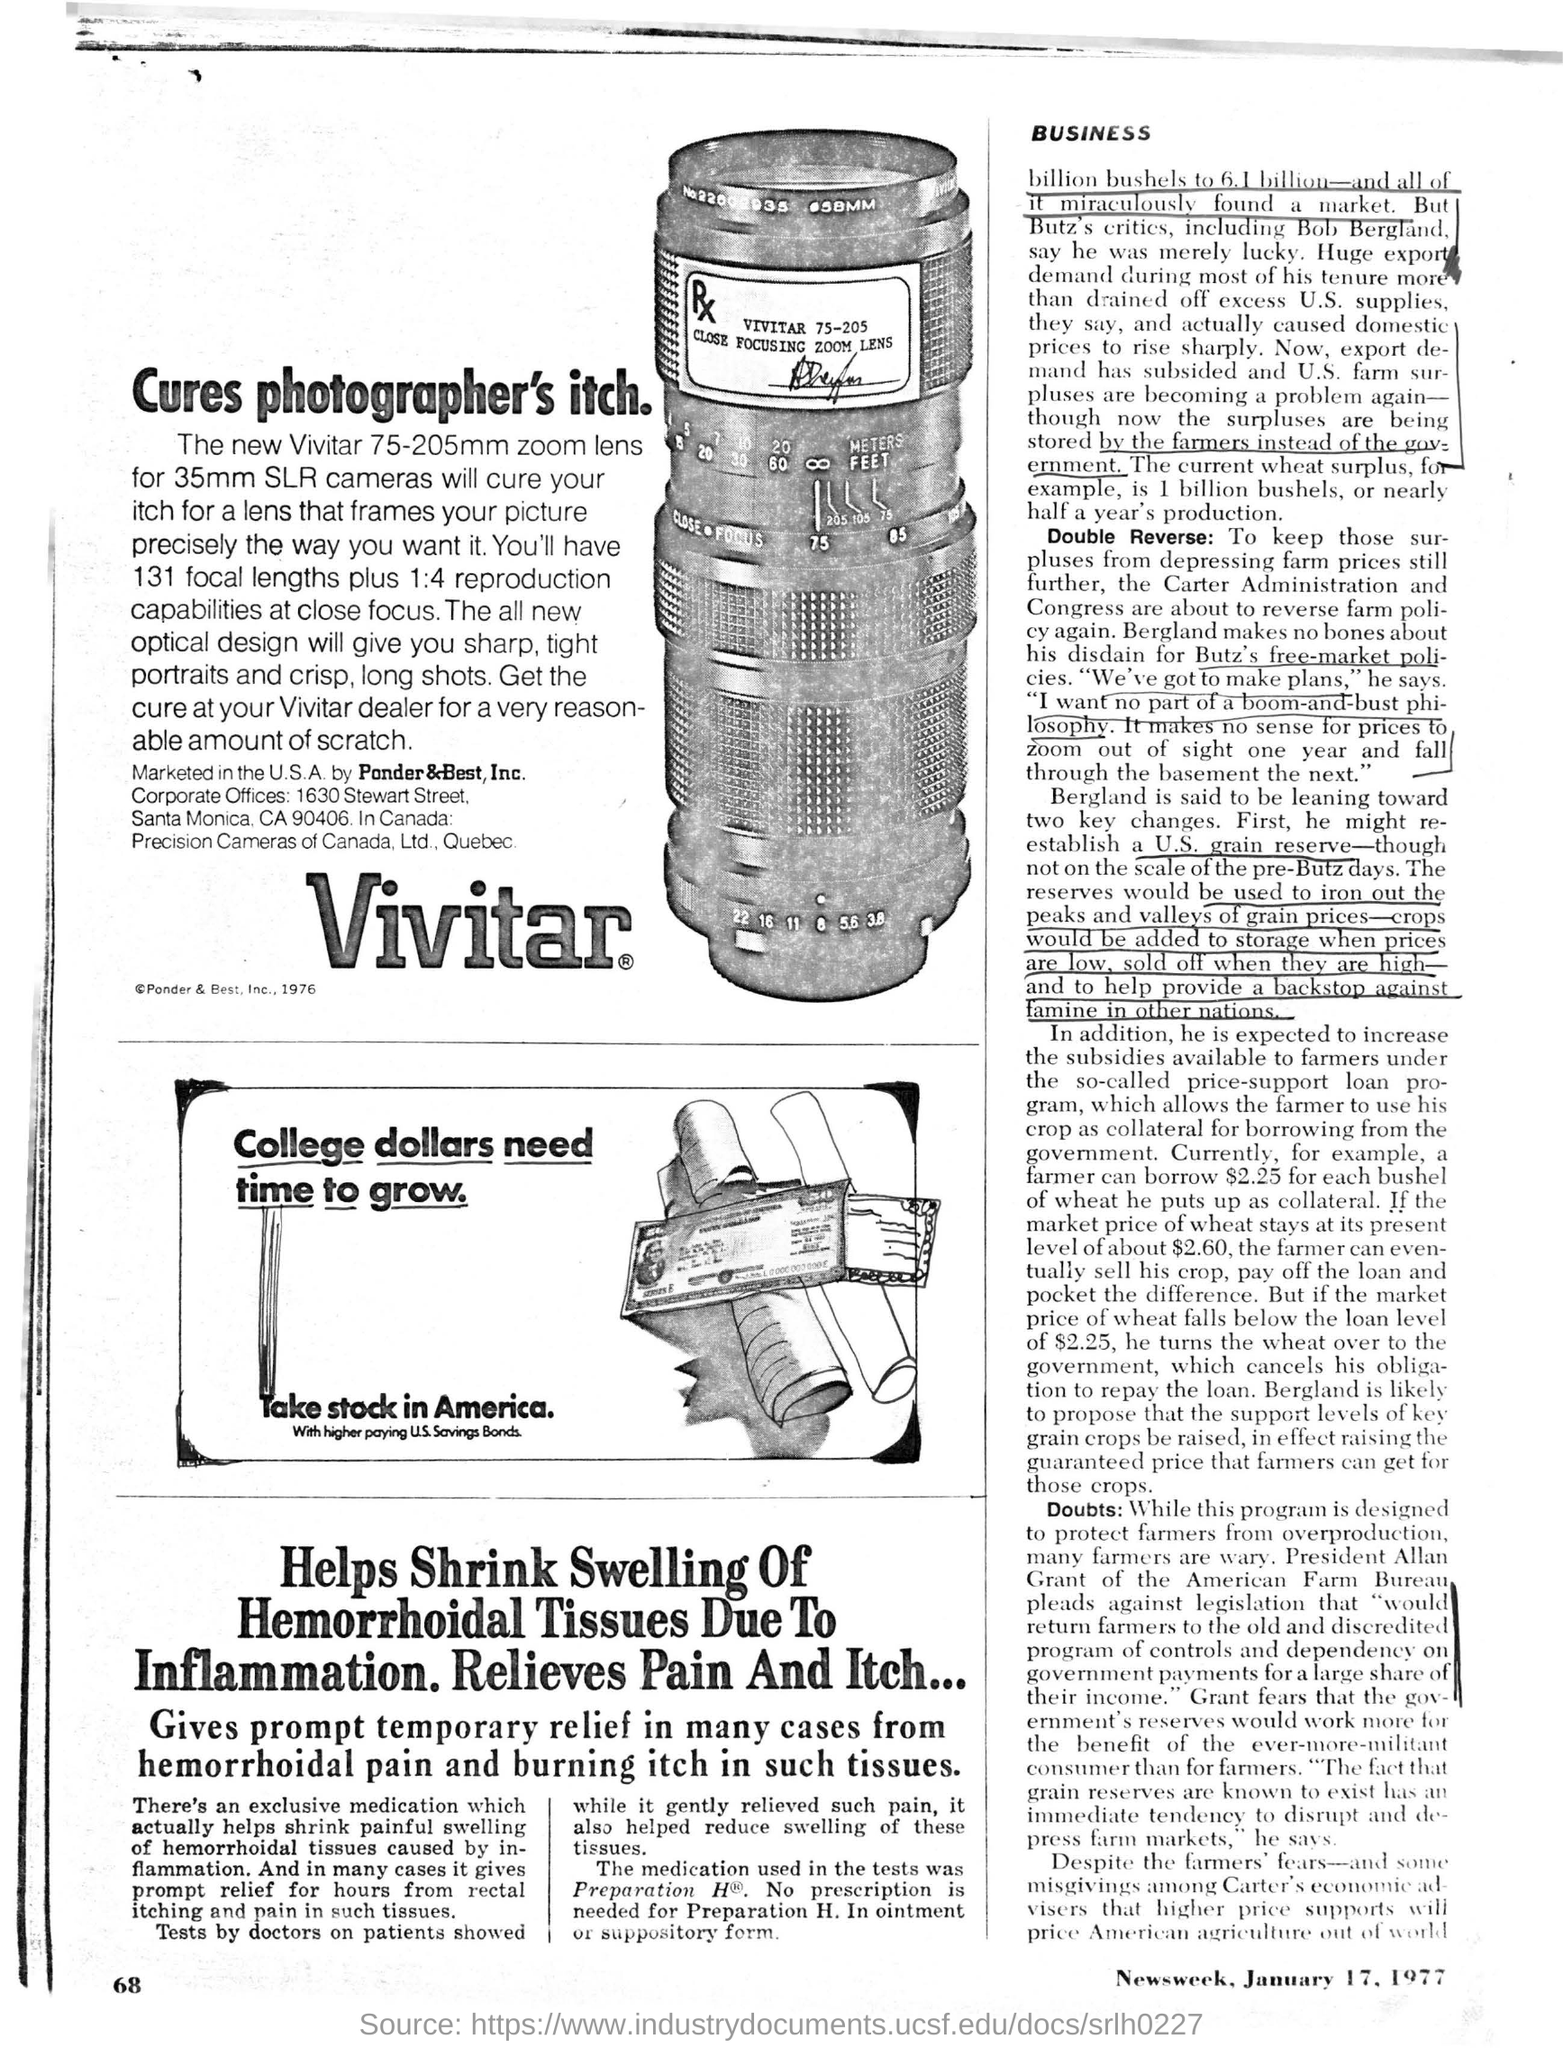What type of zoom lens is advertised for 35mm slr cameras as per the advertisement?
Ensure brevity in your answer.  75-205mm. What does the optical design provide ?
Your answer should be compact. Will give you sharp, tight portraits and crisp, long shots. What is the focal length mentioned in the advertisement?
Provide a short and direct response. 131. Which  company   markets vivitar in the u.s.a?
Your answer should be very brief. Pander&Best, Inc. What is the tag line under the title of 'take stock in america' which is at the mid of page in a box?
Your answer should be compact. With higher paying U.S. Savings Bonds. 